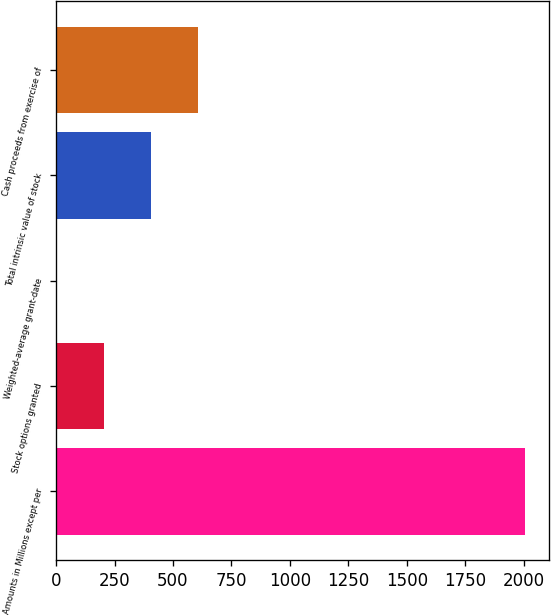Convert chart to OTSL. <chart><loc_0><loc_0><loc_500><loc_500><bar_chart><fcel>Amounts in Millions except per<fcel>Stock options granted<fcel>Weighted-average grant-date<fcel>Total intrinsic value of stock<fcel>Cash proceeds from exercise of<nl><fcel>2006<fcel>204.87<fcel>4.74<fcel>405<fcel>605.13<nl></chart> 